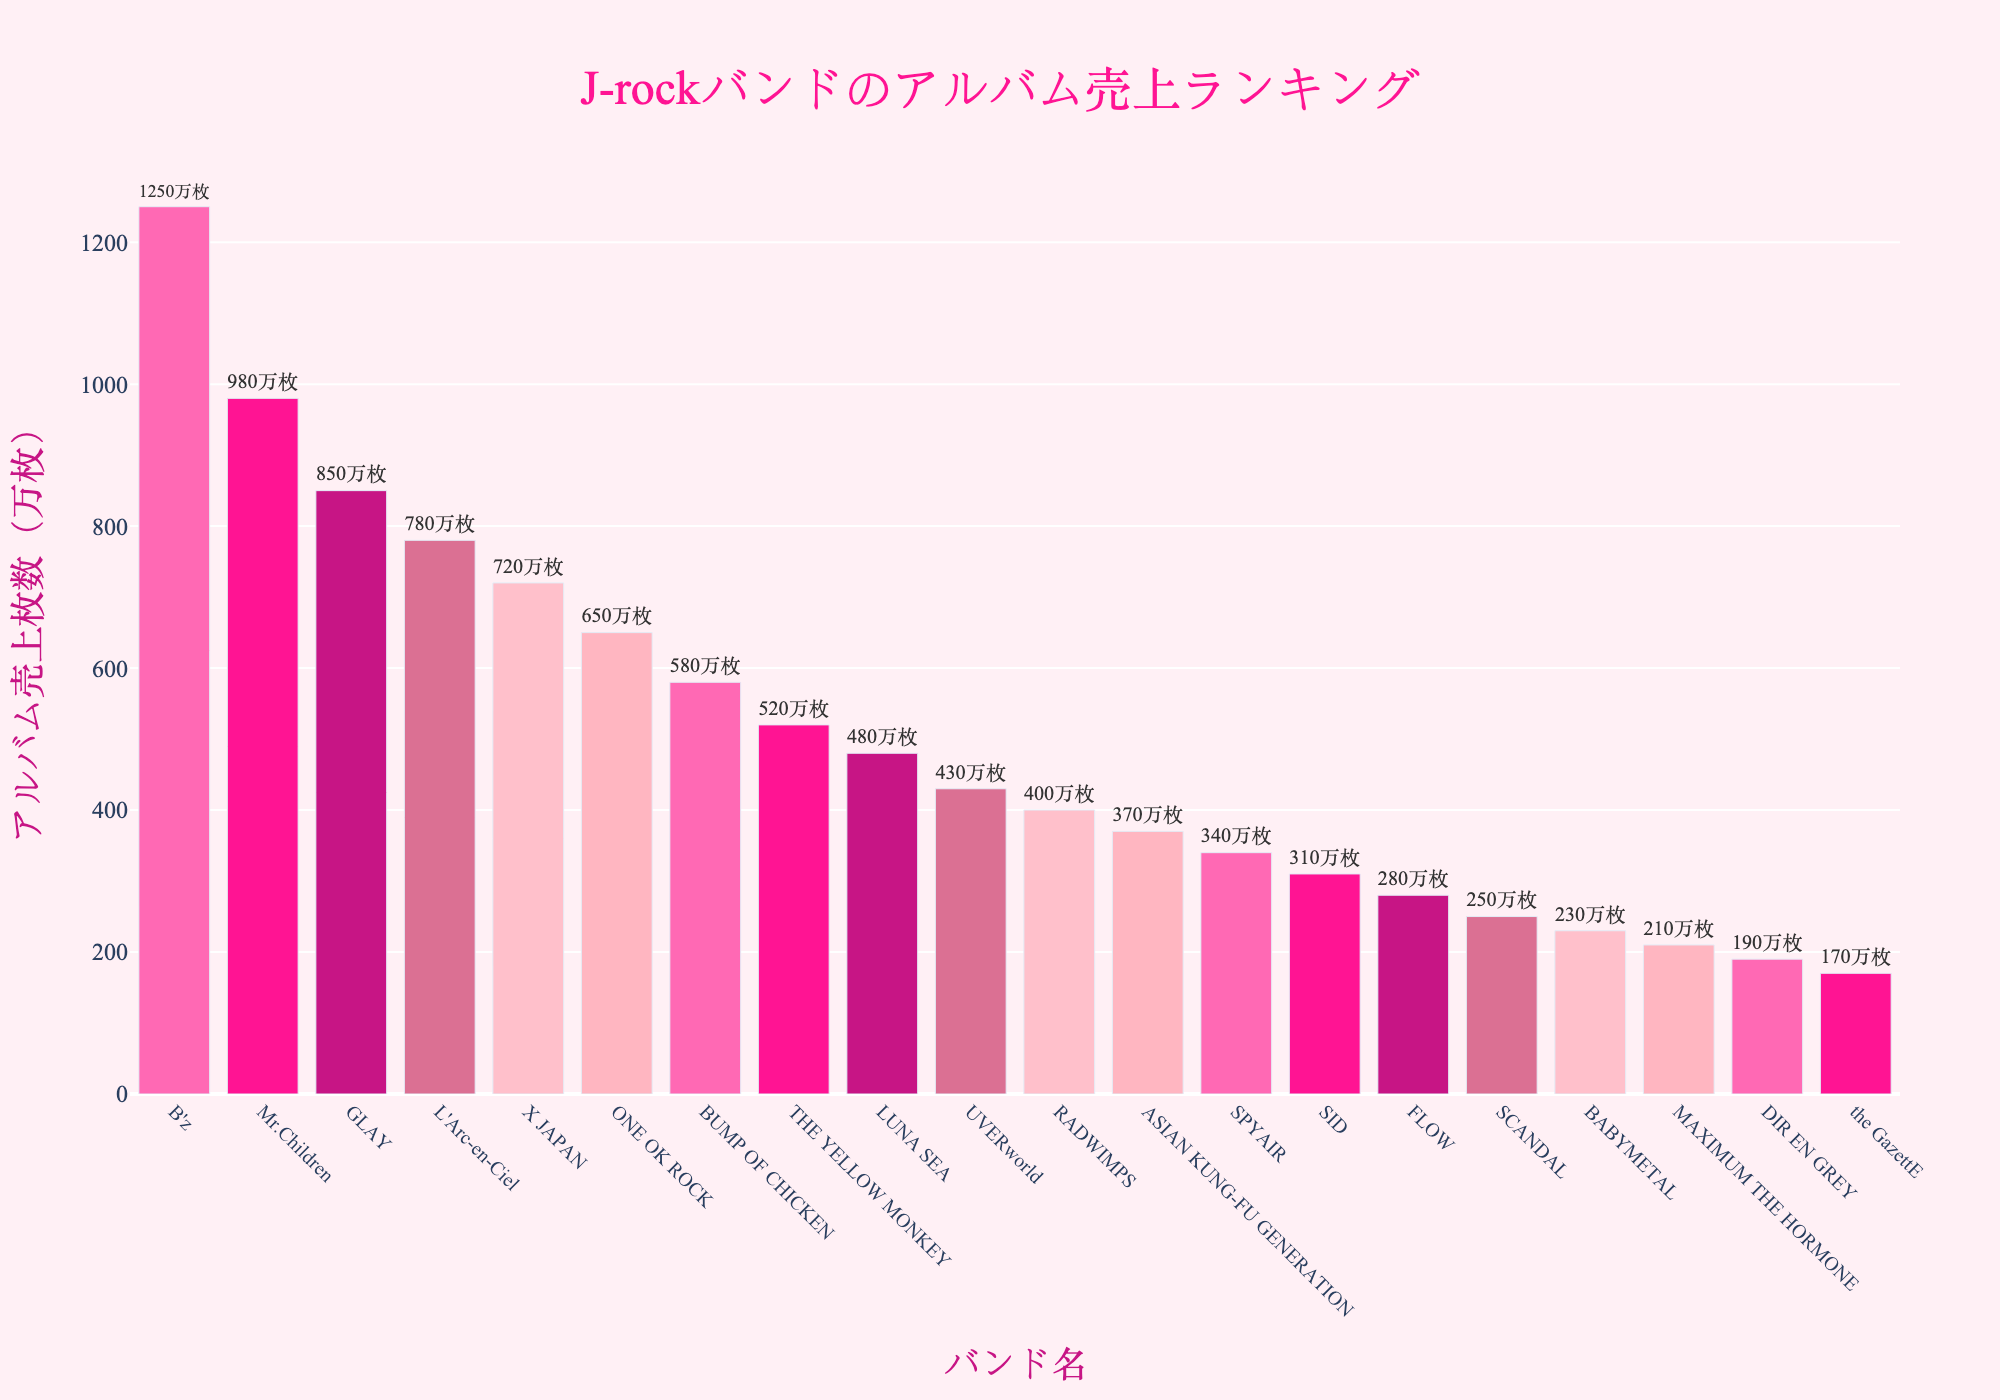What's the total album sales of the top three bands? The top three bands based on album sales are B'z, Mr.Children, and GLAY. Their album sales are 1250万枚, 980万枚, and 850万枚 respectively. The total is 1250 + 980 + 850 = 3080万枚。
Answer: 3080万枚 Which band has the highest album sales, and what is the value? The band with the highest album sales is B'z with 1250万枚。
Answer: B'z, 1250万枚 What's the difference in album sales between L'Arc-en-Ciel and X JAPAN? L'Arc-en-Ciel has album sales of 780万枚 and X JAPAN has 720万枚. The difference is 780 - 720 = 60万枚。
Answer: 60万枚 How do the album sales of the least popular band compare with the most popular band? The least popular band is the GazettE with 170万枚. The most popular band is B'z with 1250万枚. Comparing their sales, 1250 - 170 = 1080万枚。
Answer: the GazettE, 1080万枚 What is the combined album sales of bands ranked between 5th and 10th place? The bands ranked between 5th and 10th place are X JAPAN (720万枚), ONE OK ROCK (650万枚), BUMP OF CHICKEN (580万枚), THE YELLOW MONKEY (520万枚), and LUNA SEA (480万枚). The combined sales are 720 + 650 + 580 + 520 + 480 = 2950万枚。
Answer: 2950万枚 Which band has album sales closest to 500万枚? The band with album sales closest to 500万枚 is LUNA SEA with 480万枚。
Answer: LUNA SEA, 480万枚 What are the album sales of the band with the lowest sales? The band with the lowest sales is the GazettE with 170万枚。
Answer: 170万枚 How much more are UVERworld’s sales compared to RADWIMPS? UVERworld has album sales of 430万枚 and RADWIMPS has 400万枚. The difference is 430 - 400 = 30万枚。
Answer: 30万枚 What is the band ranked exactly in the middle and their album sales? With 20 bands listed, the middle rank is the 10th and 11th places, which are UVERworld (430万枚) and RADWIMPS (400万枚). Let's find the exact middle band: (10th + 11th)/2 = (10+11)/2 = 10.5. Taking the average, we average their sales: (430 + 400) / 2 = 415万枚. So the exact middle sales are 415 - not a rankable number from the data pair. The rankable middle term is earlier seen: by average ranks: 10.5 is closest manually seen as UVERworld- borderline of median
Answer: UVERworld, 430万枚 